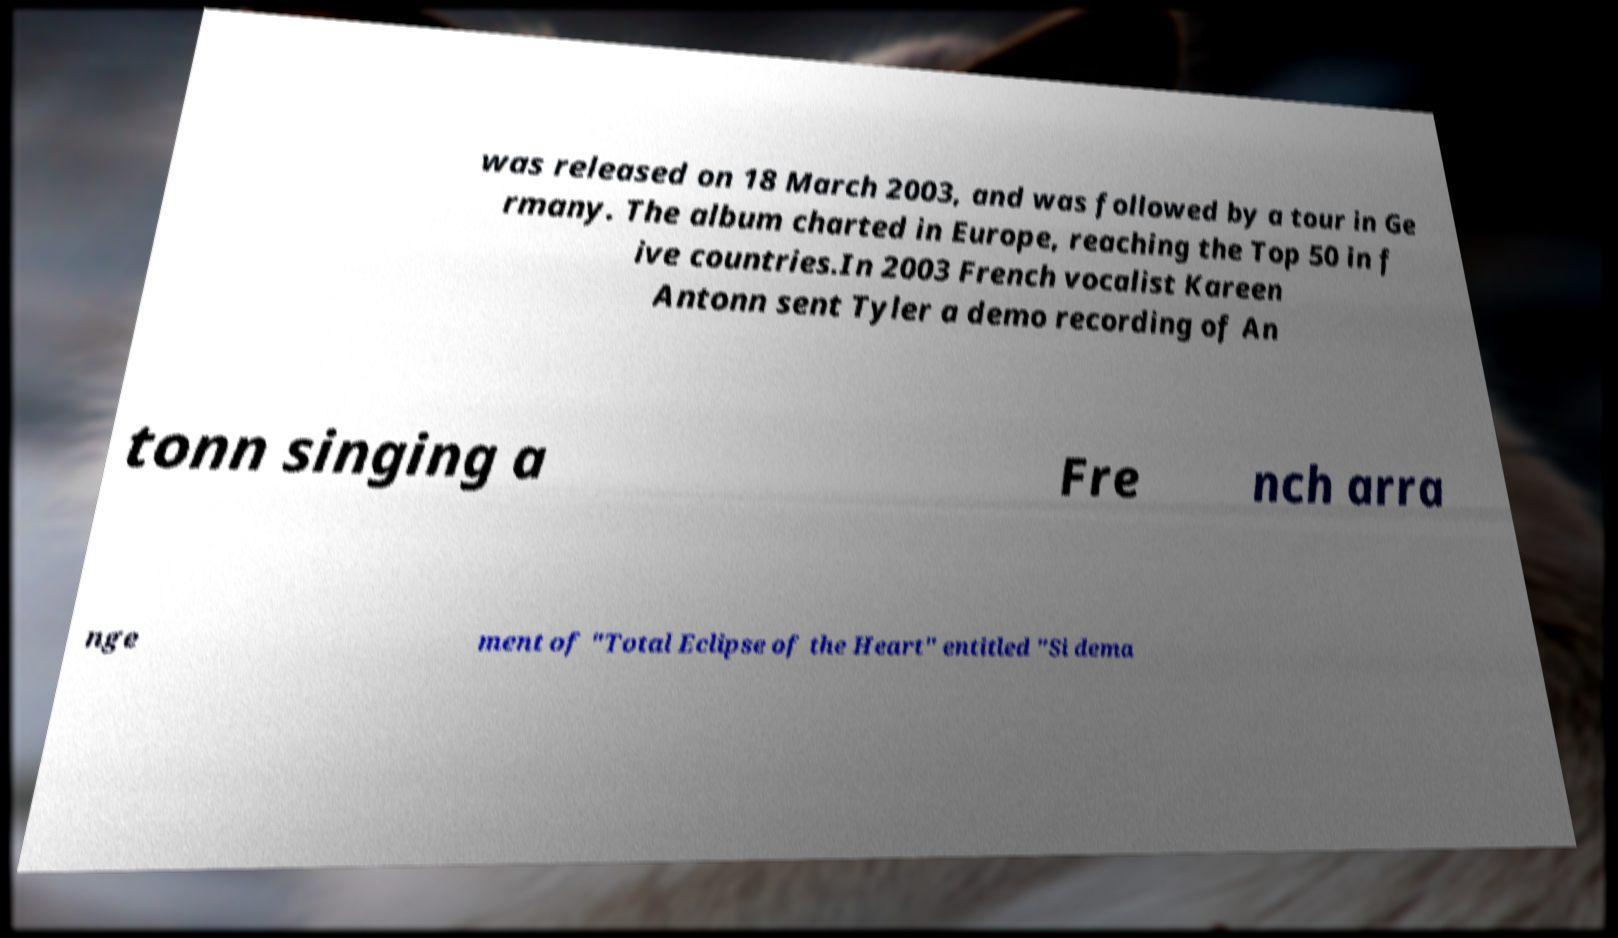What messages or text are displayed in this image? I need them in a readable, typed format. was released on 18 March 2003, and was followed by a tour in Ge rmany. The album charted in Europe, reaching the Top 50 in f ive countries.In 2003 French vocalist Kareen Antonn sent Tyler a demo recording of An tonn singing a Fre nch arra nge ment of "Total Eclipse of the Heart" entitled "Si dema 